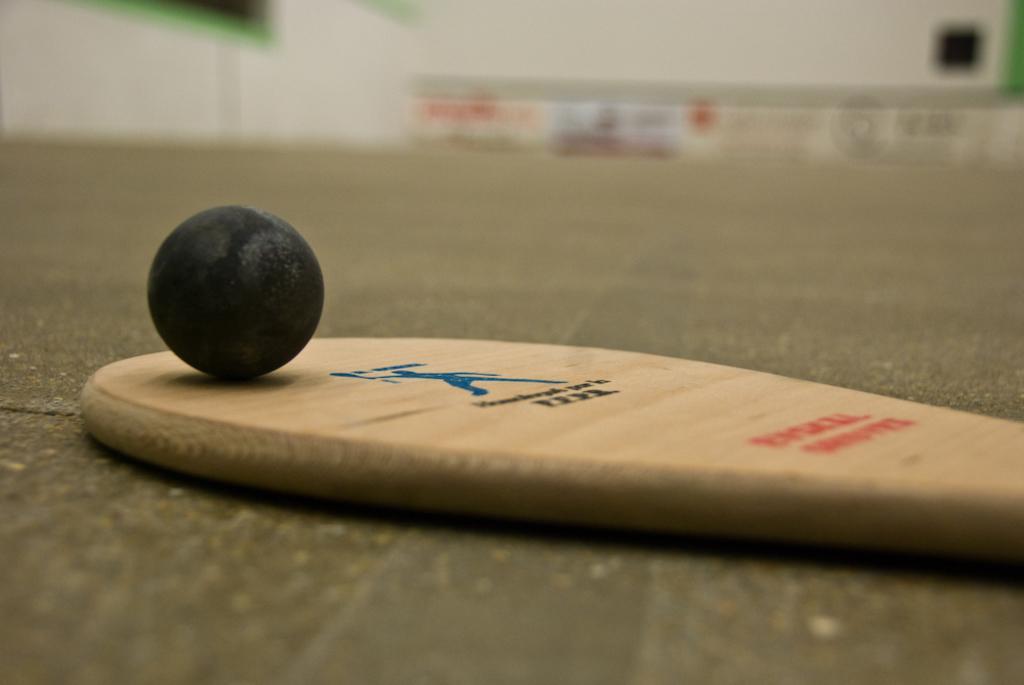Describe this image in one or two sentences. In this image I can see a cream colour bat and on it I can see a black colour ball. I can also see something is written on the bat and I can see this image is little bit blurry in the background. 